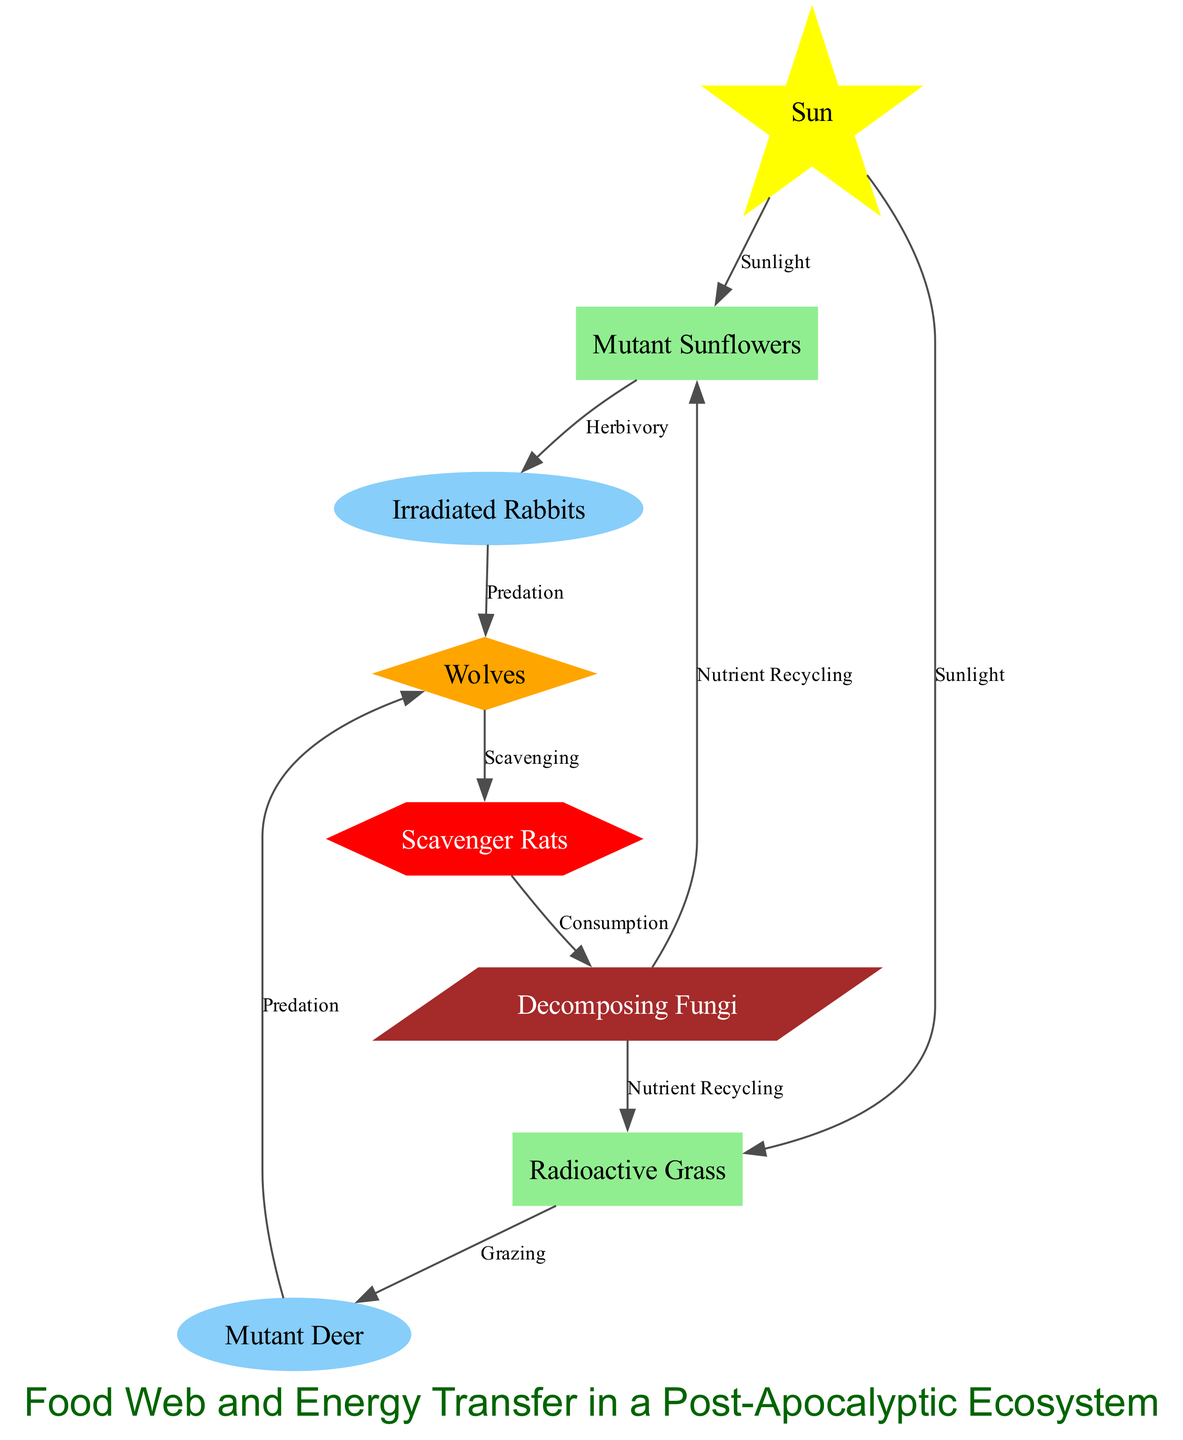What is the primary energy source in this ecosystem? The diagram indicates that the "Sun" is labeled as the "Energy Source," which directly provides energy to the producers via sunlight.
Answer: Sun How many producers are present in the food web? By counting the nodes labeled as "Producer," we find two: "Mutant Sunflowers" and "Radioactive Grass."
Answer: 2 Which consumers are classified as primary consumers? The diagram shows "Irradiated Rabbits" and "Mutant Deer" as primary consumers, as they directly feed on the producers.
Answer: Irradiated Rabbits, Mutant Deer What type of interaction occurs between "Decomposing Fungi" and the producers? The interaction labeled "Nutrient Recycling" indicates that the decomposers help return nutrients to the producers, promoting ecosystem sustainability.
Answer: Nutrient Recycling Which consumer type feeds on "Irradiated Rabbits"? According to the diagram, "Wolves" prey on "Irradiated Rabbits," demonstrating a predation relationship between these two nodes.
Answer: Wolves What role do "Scavenger Rats" play in this ecosystem? "Scavenger Rats" are classified as tertiary consumers, which indicates they feed on secondary consumers like "Wolves" by scavenging their remains.
Answer: Tertiary Consumer How does energy flow from the producers to tertiary consumers? Energy flows from the "Sun" to "Mutant Sunflowers" and "Radioactive Grass" (the producers), which are then consumed by primary consumers (e.g., "Irradiated Rabbits"), followed by secondary consumers ("Wolves") and finally to tertiary consumers ("Scavenger Rats").
Answer: Sun → Producers → Primary Consumers → Secondary Consumers → Tertiary Consumers What does the arrow labeled "Predation" represent? The "Predation" label indicates a relationship where one organism (the predator) feeds on another organism (the prey), specifically between primary consumers and secondary consumers.
Answer: Feeding relationship How many edges (arrows) are there in the food web? Counting the edges in the diagram, there are a total of 10 arrows indicating the flows of energy and consumption relationships between different organisms in the ecosystem.
Answer: 10 